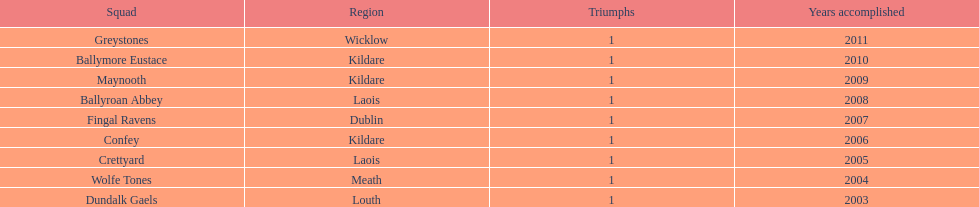How many triumphs has greystones achieved? 1. 